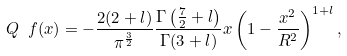<formula> <loc_0><loc_0><loc_500><loc_500>Q _ { \ } f ( x ) = - \frac { 2 ( 2 + l ) } { \pi ^ { \frac { 3 } { 2 } } } \frac { \Gamma \left ( \frac { 7 } { 2 } + l \right ) } { \Gamma ( 3 + l ) } x \left ( 1 - \frac { x ^ { 2 } } { R ^ { 2 } } \right ) ^ { 1 + l } ,</formula> 